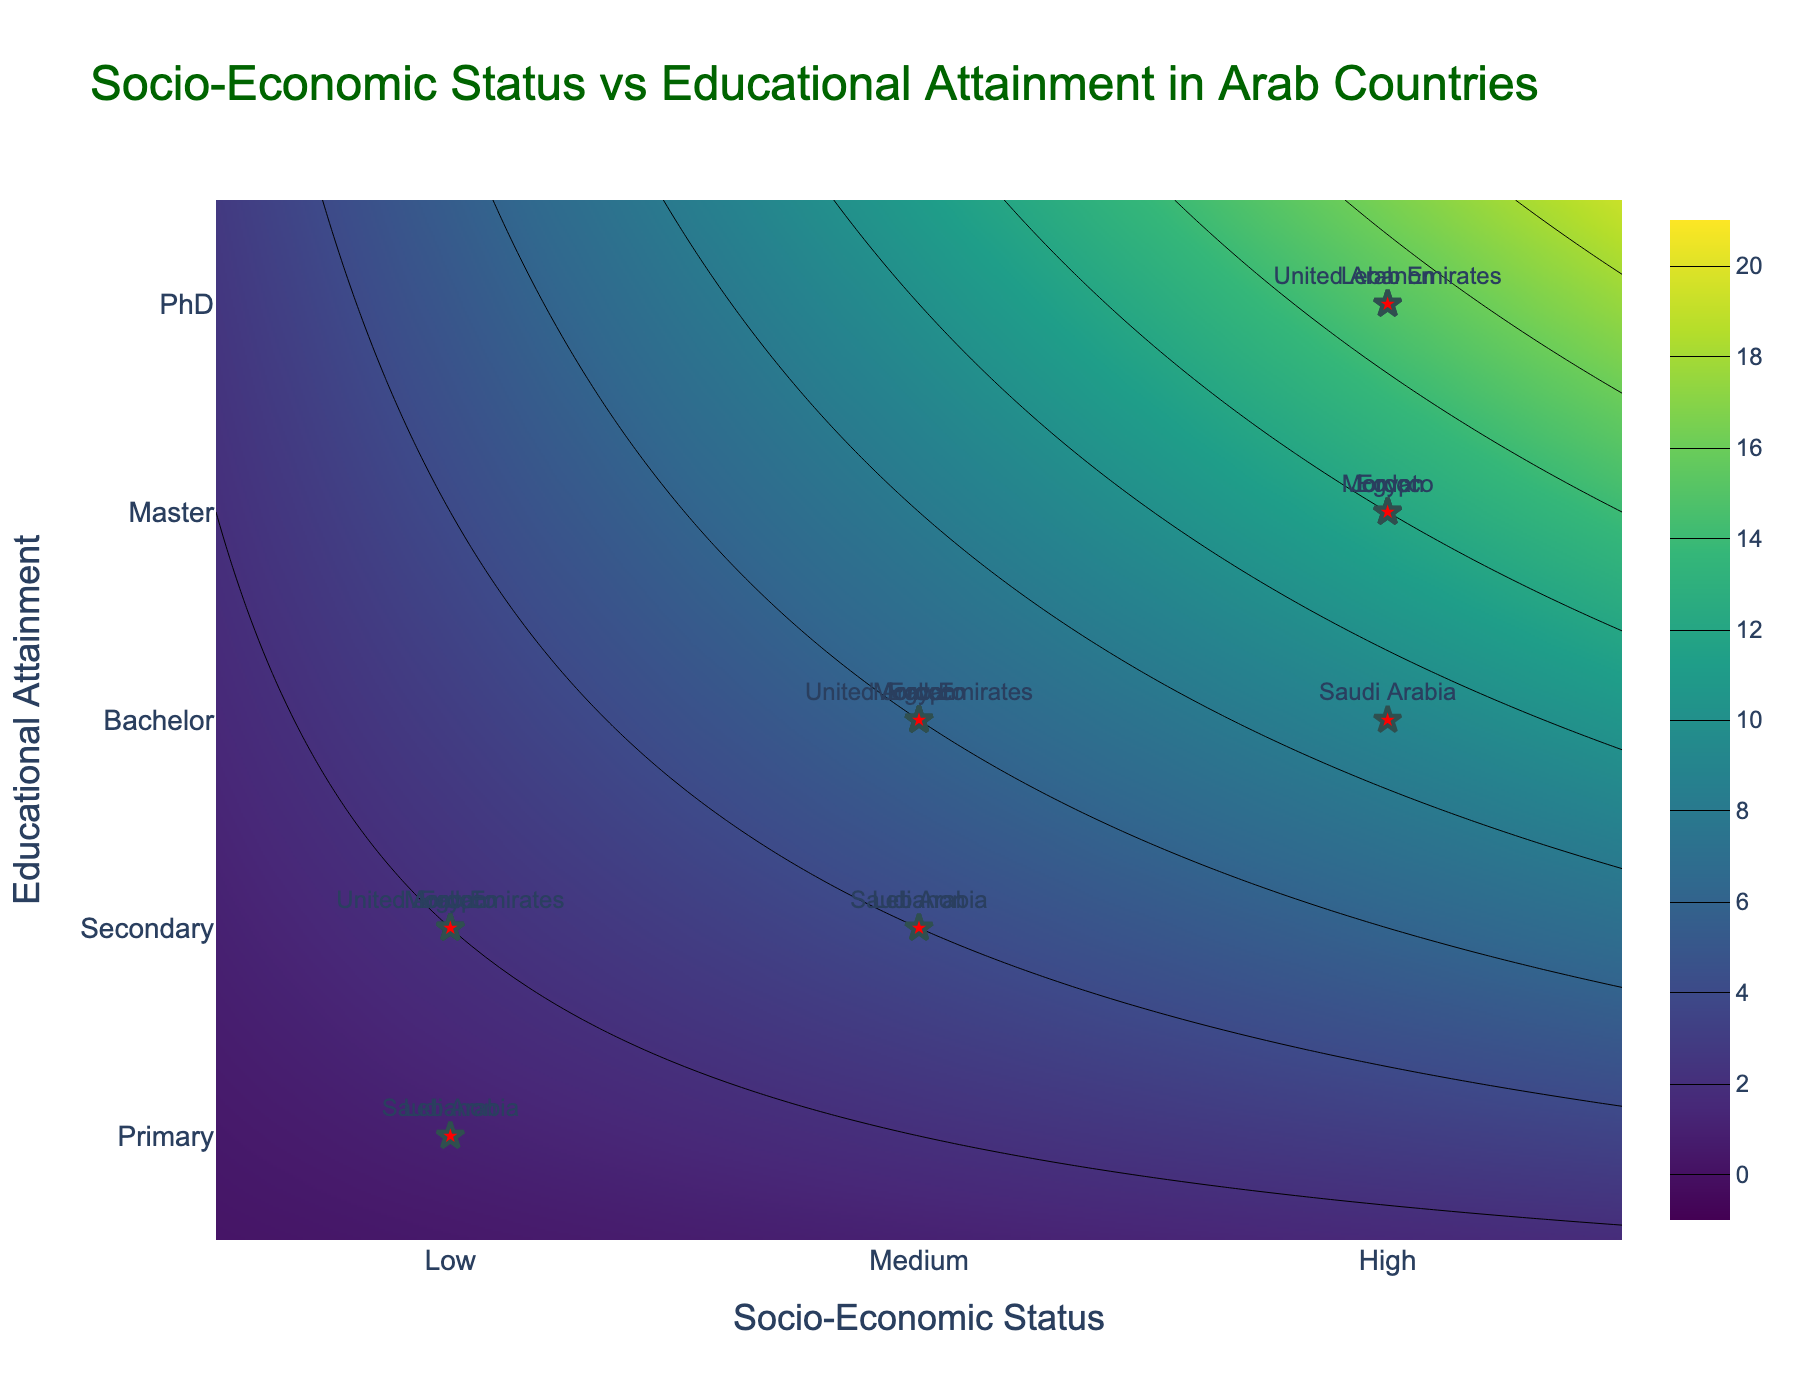What is the title of the plot? The title is always displayed at the top of the plot, providing a summary of what the figure represents. Here, it says, "Socio-Economic Status vs Educational Attainment in Arab Countries".
Answer: Socio-Economic Status vs Educational Attainment in Arab Countries How many distinct Socio-Economic Status levels are represented in the plot? The x-axis shows the different levels of Socio-Economic Status as "Low", "Medium", and "High". These correspond to three distinct levels.
Answer: Three What types of Educational Attainment are displayed in the plot? The y-axis shows the levels of Educational Attainment, which are "Primary", "Secondary", "Bachelor", "Master", and "PhD", totaling five types.
Answer: Five types: Primary, Secondary, Bachelor, Master, PhD Which country has the highest level of Educational Attainment shown in the plot? To find the highest level of Educational Attainment, look at the data points on the upper end of the y-axis. The country placed highest on the y-axis is Lebanon, with a PhD.
Answer: Lebanon How many countries have a Socio-Economic Status level of 'Medium' represented in the plot? Points representing countries with 'Medium' SES fall on the x-axis value of 2. Observing these, Egypt, Lebanon, Jordan, Saudi Arabia, Morocco, and the United Arab Emirates are visible, making six countries.
Answer: Six Compare the Educational Attainments between countries with 'High' Socio-Economic Status. Which country has the highest and which has the lowest? The x-axis value of 3 represents 'High' Socio-Economic Status. Observing these points, Lebanon (PhD) is higher than the others. Saudi Arabia (Bachelor) is the lowest among those with 'High' SES.
Answer: Lebanon highest, Saudi Arabia lowest What is the most common Educational Attainment level among countries with 'Low' Socio-Economic Status? On the x-axis value of 1, inspect all corresponding y-axis values. The points show Egypt in Secondary, Lebanon in Primary, Jordan in Secondary, Saudi Arabia in Primary, Morocco in Secondary, and the UAE in Secondary. The most common value here is Secondary.
Answer: Secondary What is the relationship between Socio-Economic Status and Educational Attainment based on the contour lines? Contour lines help visualize regions of high density and gradients. Observing their directions and dense areas, a general trend is visible where higher Socio-Economic Status aligns with higher Educational Attainment.
Answer: Higher SES generally aligns with higher Educational Attainment Is there any outlier among the countries based on their placement in the contour plot? Outliers are points significantly deviating from others' patterns. All countries follow a clear pattern without significant deviations based on their Socio-Economic Status and Educational Attainment placements.
Answer: No significant outliers Which region has the broadest range of Educational Attainment levels, and what are those levels? Observing where multiple y-axis values connect to a singular country on the x-axis, Cairo (Egypt) shows Secondary (Low), Bachelor (Medium), and Master (High). Hence, Cairo has a wide range of Educational Attainment levels.
Answer: Cairo: Secondary, Bachelor, Master 